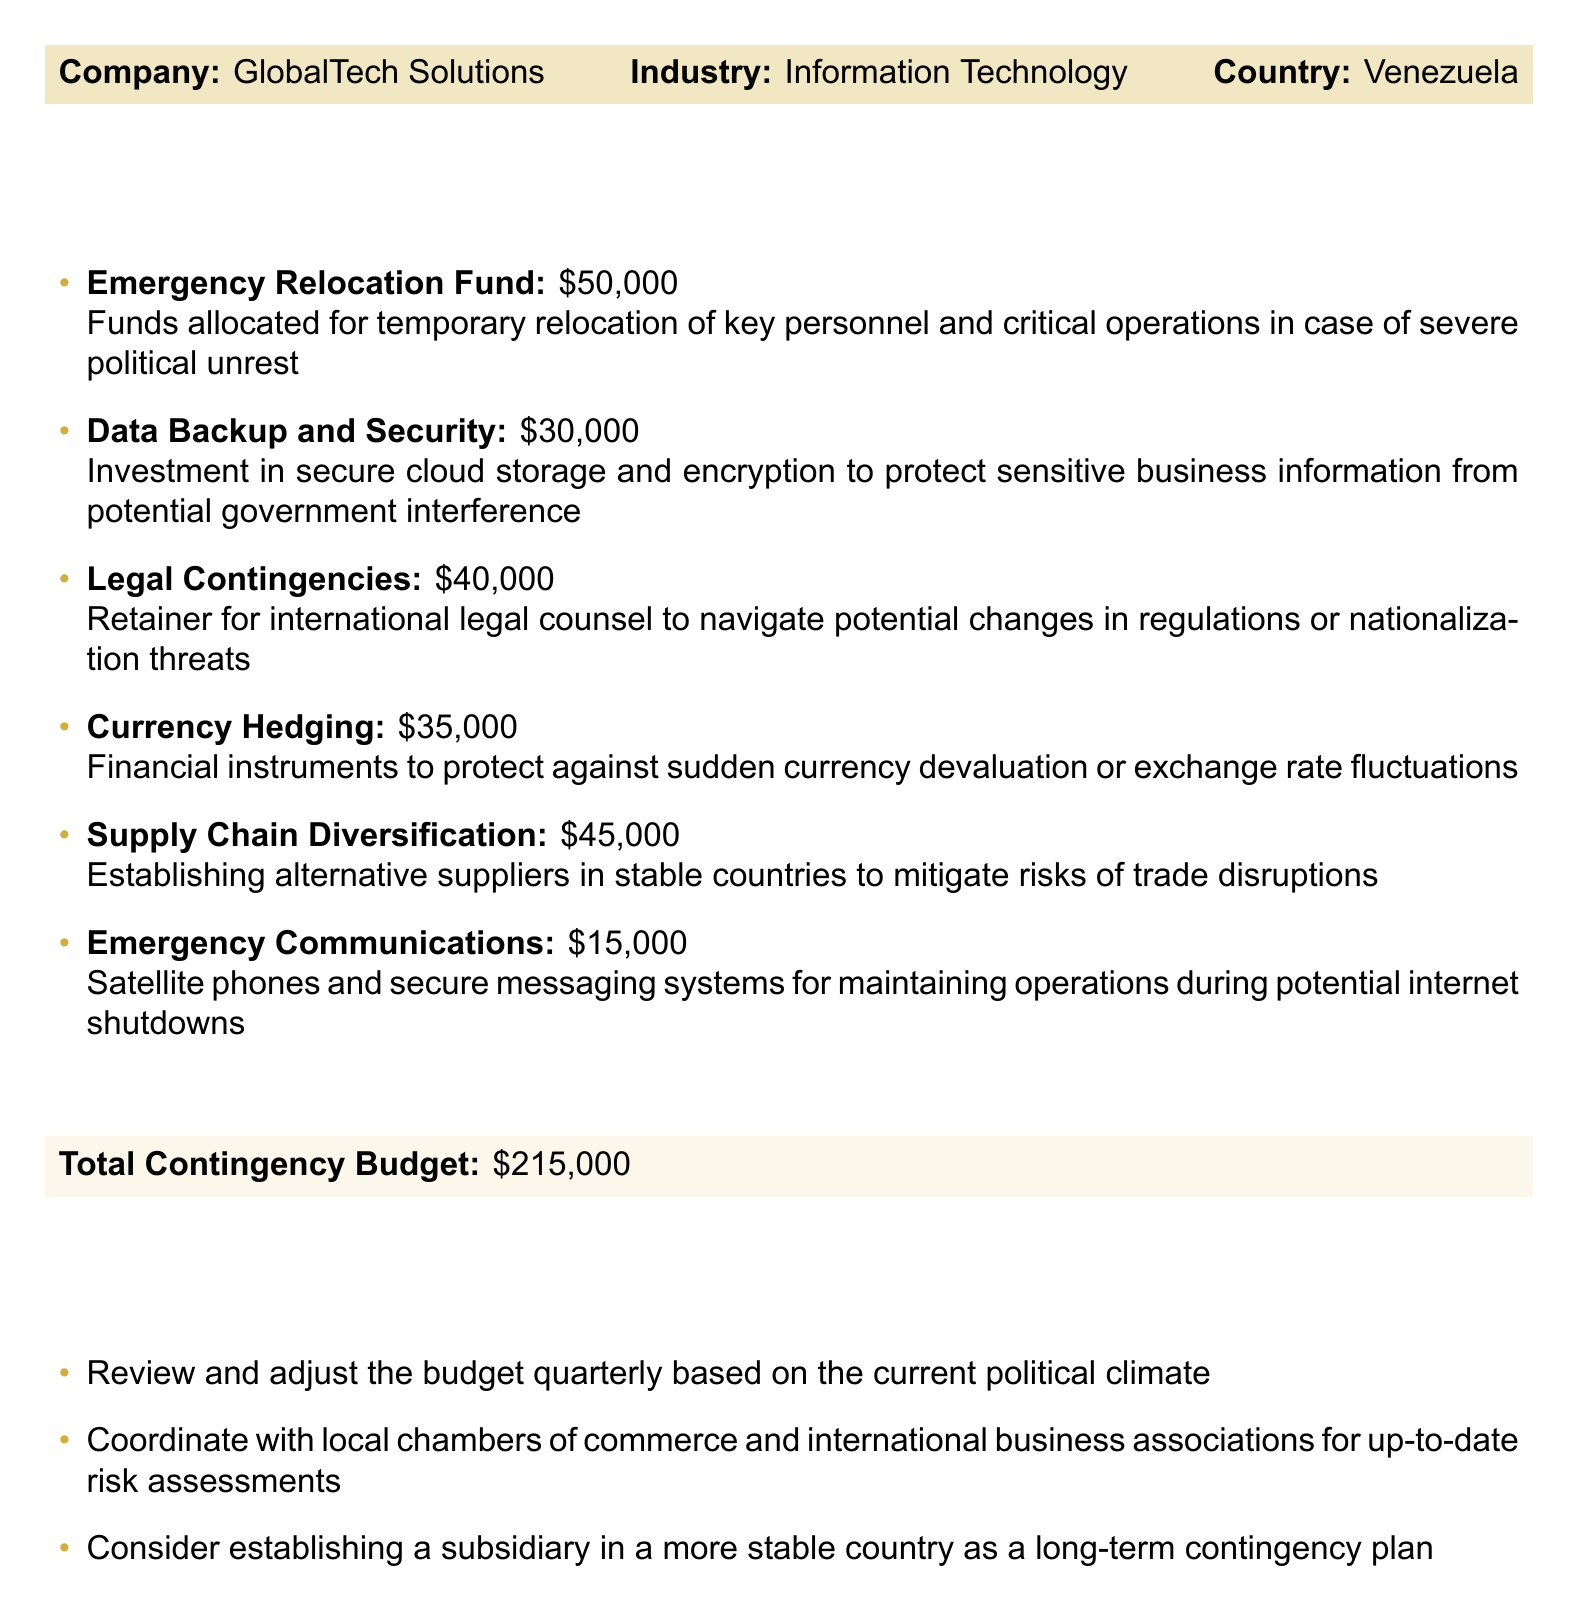What is the total contingency budget? The total contingency budget is stated at the end of the budget section, summarizing all allocated funds.
Answer: $215,000 What is allocated for currency hedging? The budget lists specific amounts for each category, including currency hedging.
Answer: $35,000 What is the purpose of the emergency relocation fund? The document describes the emergency relocation fund's purpose as preparing for temporary relocation due to political unrest.
Answer: Temporary relocation of key personnel How much is budgeted for data backup and security? The budget itemizes the allocation for data backup and security, showing specific amounts assigned.
Answer: $30,000 What is one of the budget notes regarding budget review? The document includes notes about budget management, including recommendations for review.
Answer: Review and adjust the budget quarterly Which country is the business based in? The company information at the top of the document identifies the country in which the business operates.
Answer: Venezuela What amount is set aside for legal contingencies? The amount specifically allocated for legal contingencies is provided in the budget breakdown.
Answer: $40,000 What type of communications systems are included in the budget? The budget specifies emergency communications systems designed to maintain operations.
Answer: Satellite phones and secure messaging systems What is the purpose of supply chain diversification? The budget explains the rationale behind establishing alternative suppliers.
Answer: Mitigate risks of trade disruptions 